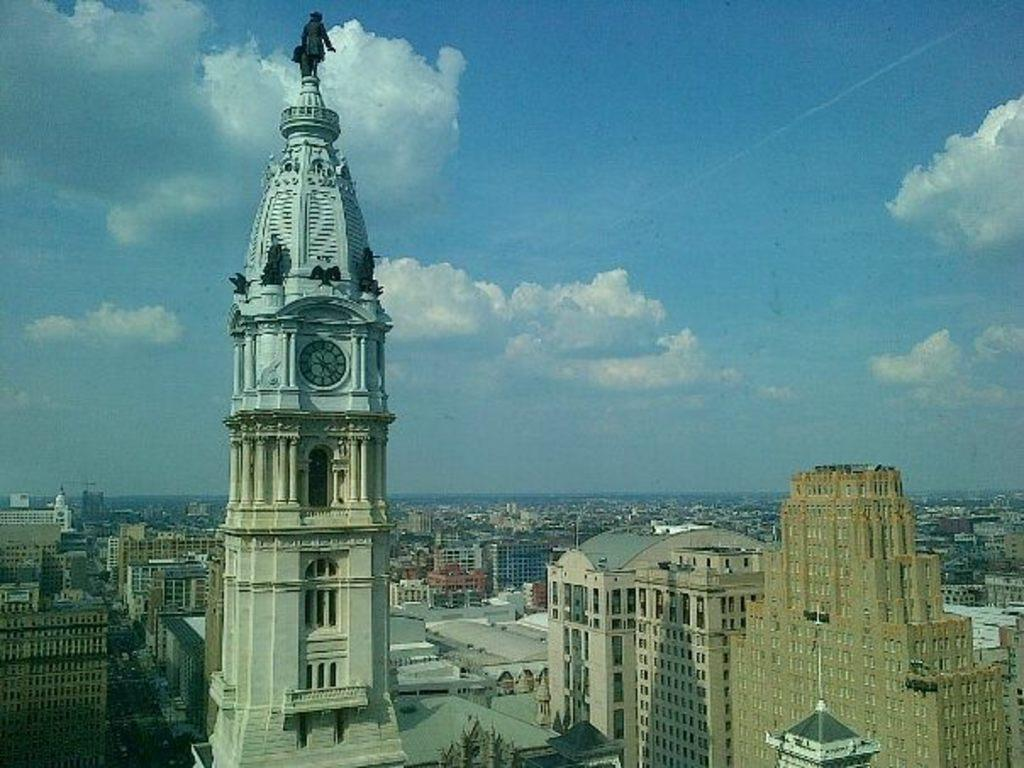What is the main structure in the image? There is a clock tower in the image. What is on top of the clock tower? The clock tower has a statue on top of it. What else can be seen in the image besides the clock tower? There are buildings in the image. What is visible at the top of the image? The sky is visible at the top of the image. What can be observed in the sky? Clouds are present in the sky. How many ducks are swimming in the clock tower's fountain in the image? There is no fountain or ducks present in the image; it features a clock tower with a statue on top and buildings in the background. 